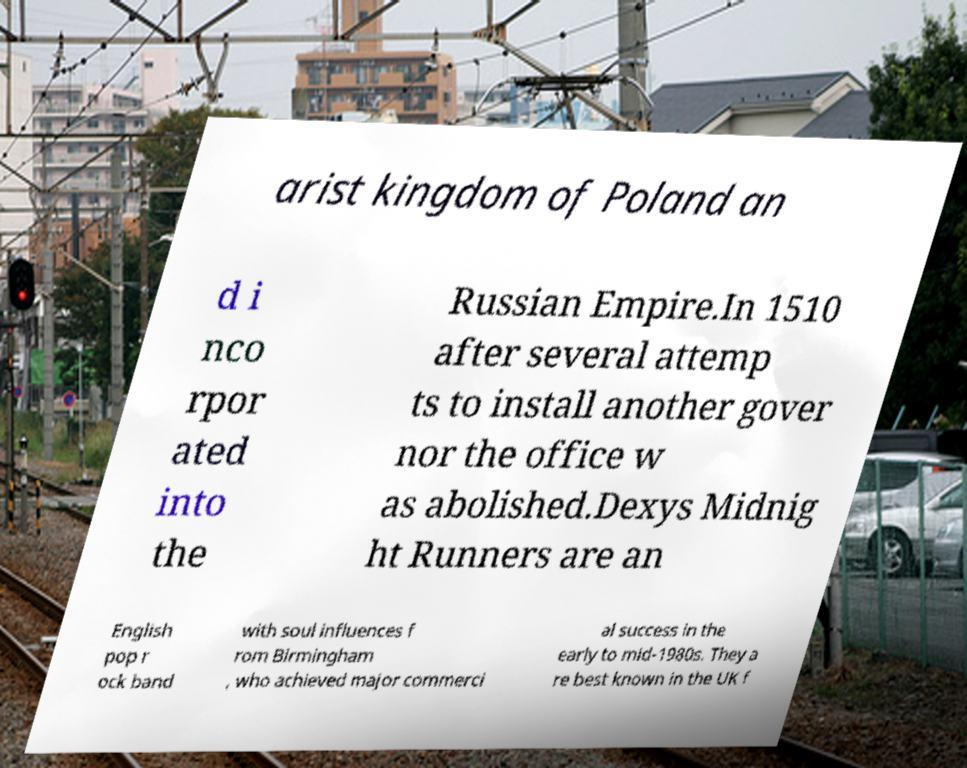I need the written content from this picture converted into text. Can you do that? arist kingdom of Poland an d i nco rpor ated into the Russian Empire.In 1510 after several attemp ts to install another gover nor the office w as abolished.Dexys Midnig ht Runners are an English pop r ock band with soul influences f rom Birmingham , who achieved major commerci al success in the early to mid-1980s. They a re best known in the UK f 